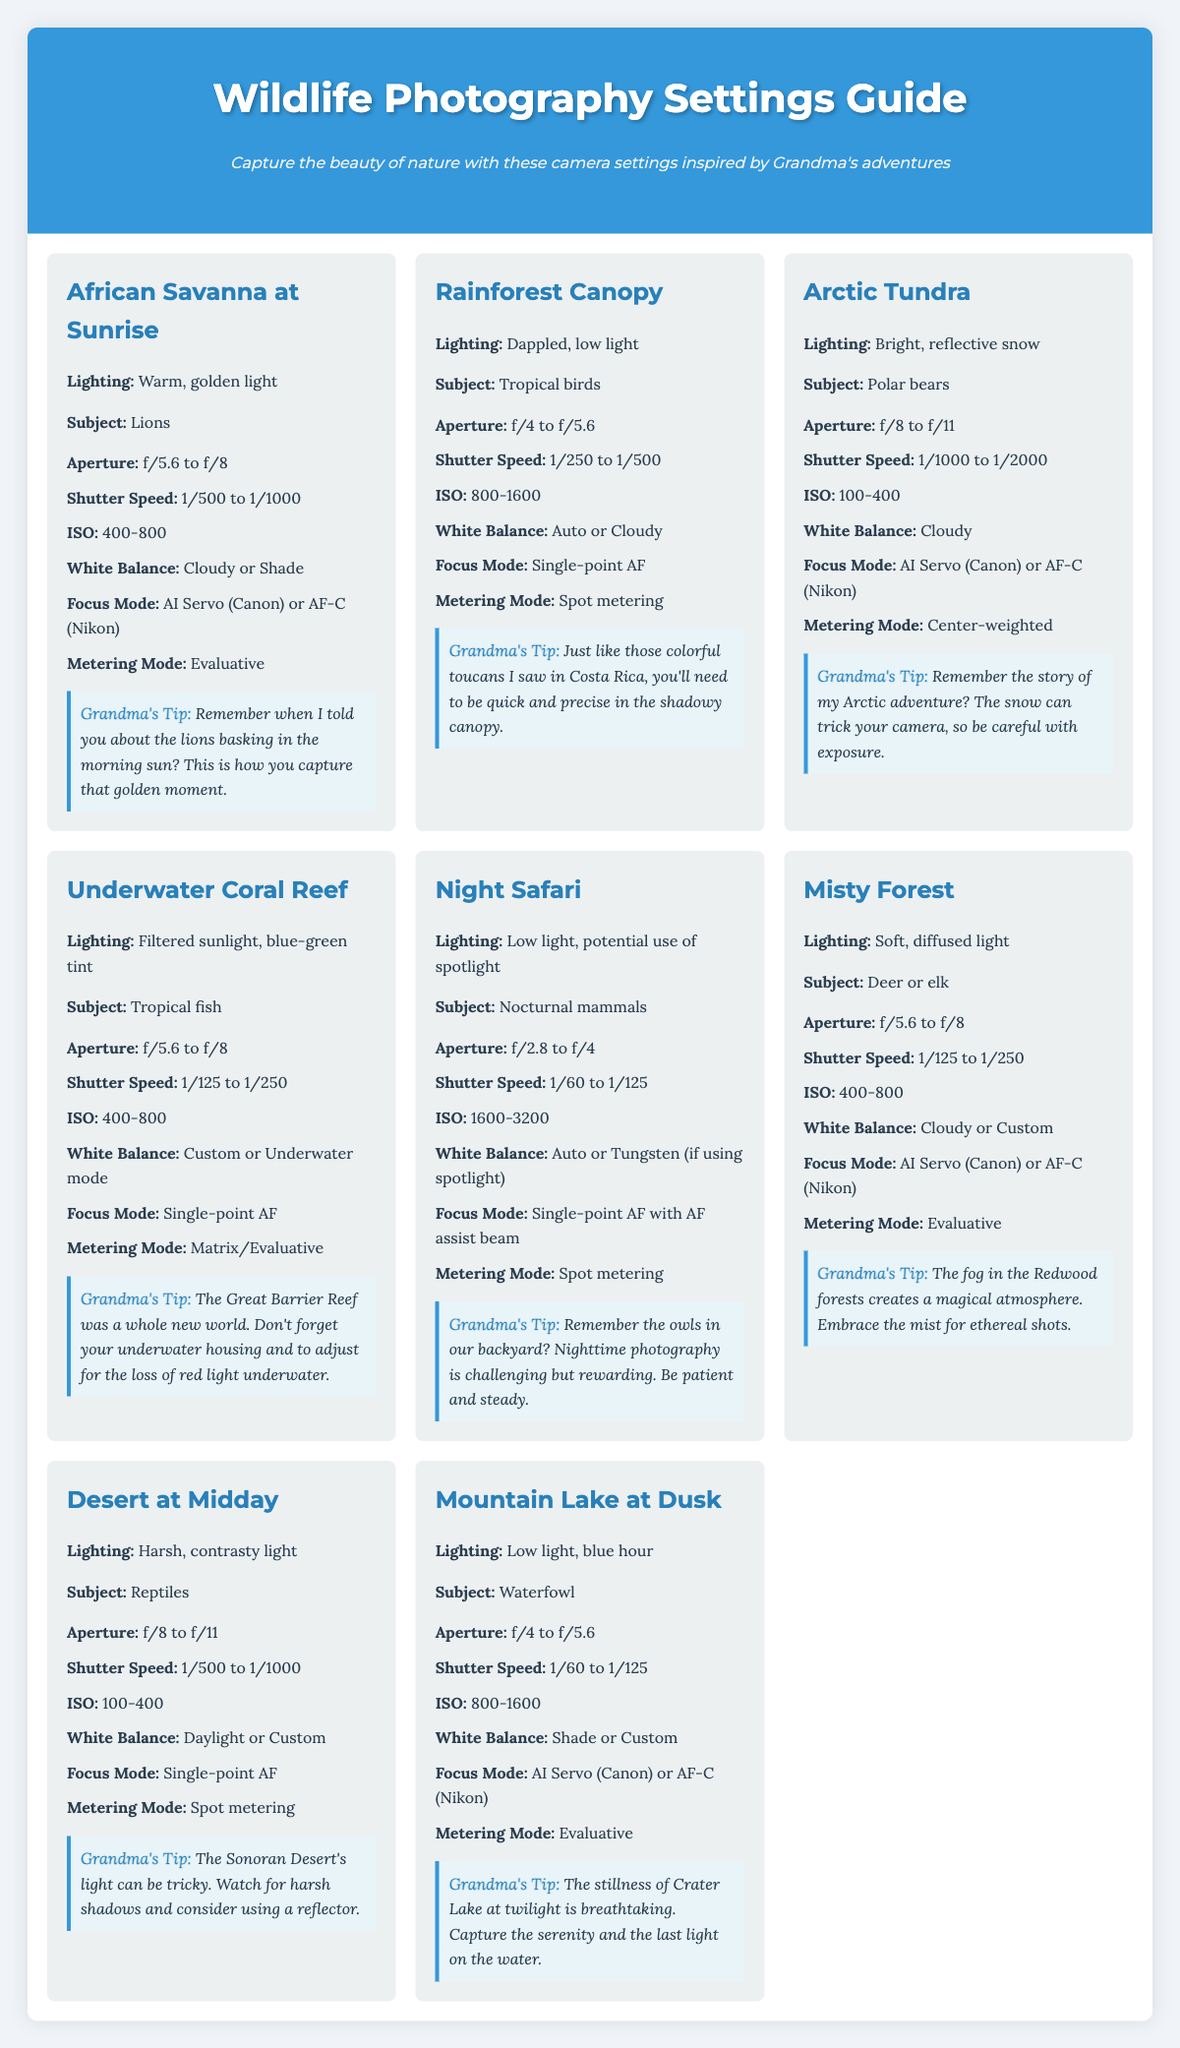what is the recommended aperture for photographing lions at sunrise? The recommended aperture for lions at sunrise is between f/5.6 and f/8.
Answer: f/5.6 to f/8 what lighting condition is associated with the rainforest canopy? The lighting condition for the rainforest canopy is described as dappled, low light.
Answer: Dappled, low light what is the ideal ISO setting when photographing polar bears in the Arctic tundra? The ideal ISO setting for polar bears in the Arctic tundra is between 100 and 400.
Answer: 100-400 how should you set the white balance when photographing tropical birds? When photographing tropical birds, the white balance should be set to Auto or Cloudy.
Answer: Auto or Cloudy which focus mode is suggested for nighttime photography of nocturnal mammals? The suggested focus mode for nighttime photography of nocturnal mammals is Single-point AF with AF assist beam.
Answer: Single-point AF with AF assist beam what is the shutter speed range for capturing deer in a misty forest? The shutter speed range for capturing deer in a misty forest is from 1/125 to 1/250.
Answer: 1/125 to 1/250 which scenario suggests using a custom white balance setting due to underwater conditions? The Underwater Coral Reef scenario suggests using a custom white balance setting.
Answer: Underwater Coral Reef what grandma tip is included for capturing wildlife in the desert at midday? The tip advises to watch for harsh shadows and consider using a reflector.
Answer: Watch for harsh shadows and consider using a reflector what metering mode is recommended for taking pictures in the African savanna? The recommended metering mode for the African savanna is Evaluative.
Answer: Evaluative 